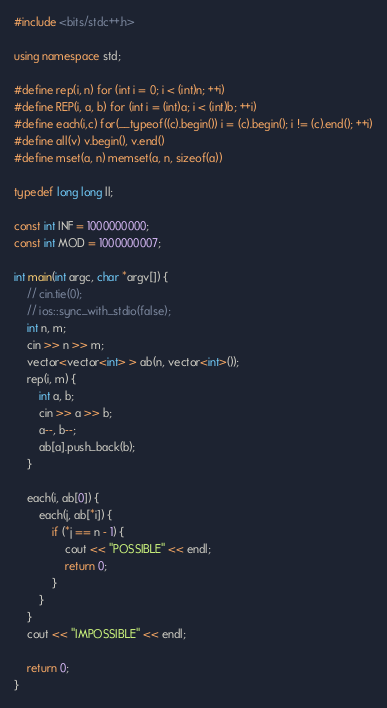Convert code to text. <code><loc_0><loc_0><loc_500><loc_500><_C++_>#include <bits/stdc++.h>

using namespace std;

#define rep(i, n) for (int i = 0; i < (int)n; ++i)
#define REP(i, a, b) for (int i = (int)a; i < (int)b; ++i)
#define each(i,c) for(__typeof((c).begin()) i = (c).begin(); i != (c).end(); ++i)
#define all(v) v.begin(), v.end()
#define mset(a, n) memset(a, n, sizeof(a))

typedef long long ll;

const int INF = 1000000000;
const int MOD = 1000000007;

int main(int argc, char *argv[]) {
    // cin.tie(0);
    // ios::sync_with_stdio(false);
    int n, m;
    cin >> n >> m;
    vector<vector<int> > ab(n, vector<int>());
    rep(i, m) {
        int a, b;
        cin >> a >> b;
        a--, b--;
        ab[a].push_back(b);
    }

    each(i, ab[0]) {
        each(j, ab[*i]) {
            if (*j == n - 1) {
                cout << "POSSIBLE" << endl;
                return 0;
            }
        }
    }
    cout << "IMPOSSIBLE" << endl;

    return 0;
}</code> 